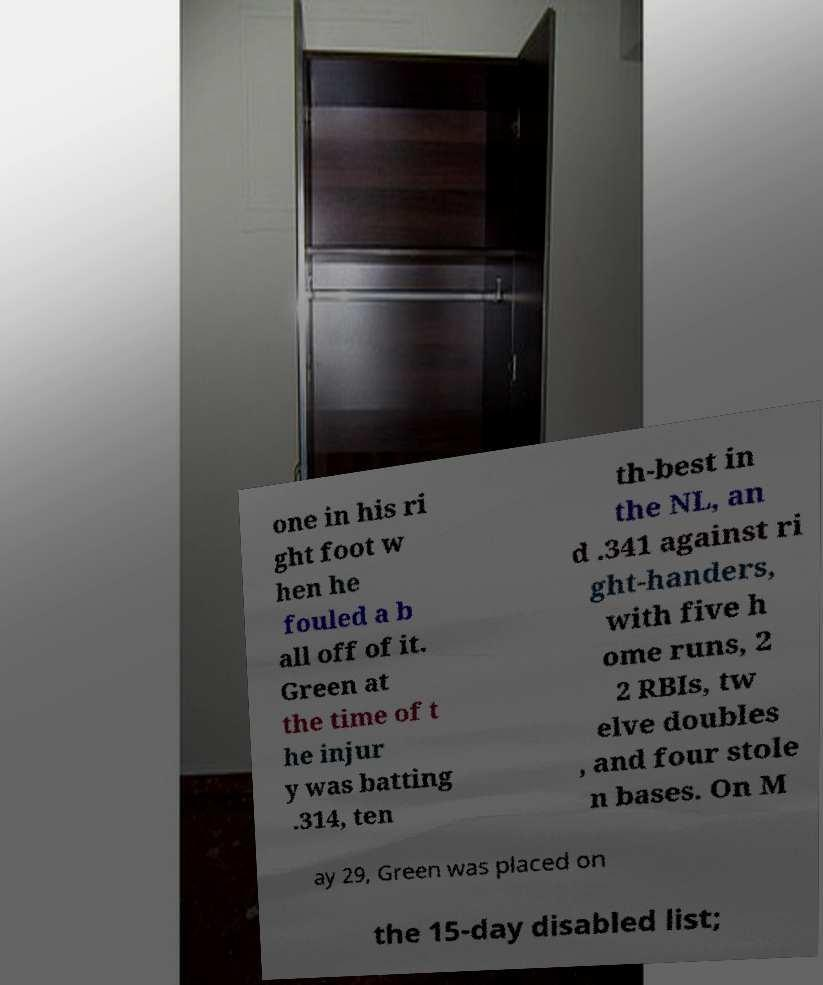Please read and relay the text visible in this image. What does it say? one in his ri ght foot w hen he fouled a b all off of it. Green at the time of t he injur y was batting .314, ten th-best in the NL, an d .341 against ri ght-handers, with five h ome runs, 2 2 RBIs, tw elve doubles , and four stole n bases. On M ay 29, Green was placed on the 15-day disabled list; 